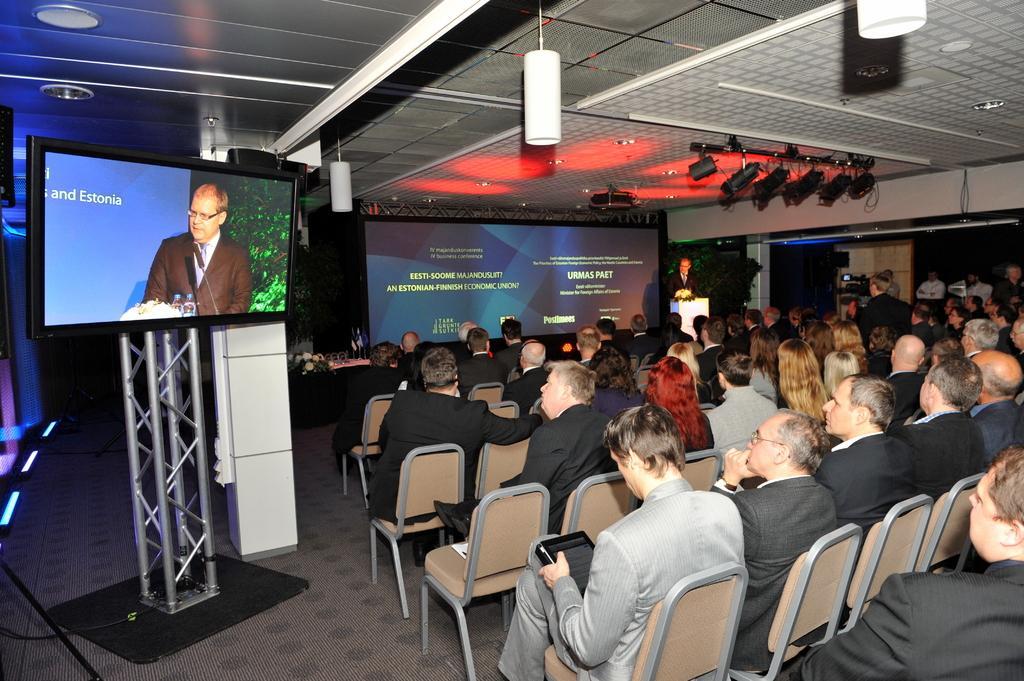Please provide a concise description of this image. In this picture we can see man standing at podium and talking and in front of him there is a group of people sitting on chair and looking at him and in background we can see screen. 